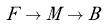Convert formula to latex. <formula><loc_0><loc_0><loc_500><loc_500>F \to M \to B</formula> 